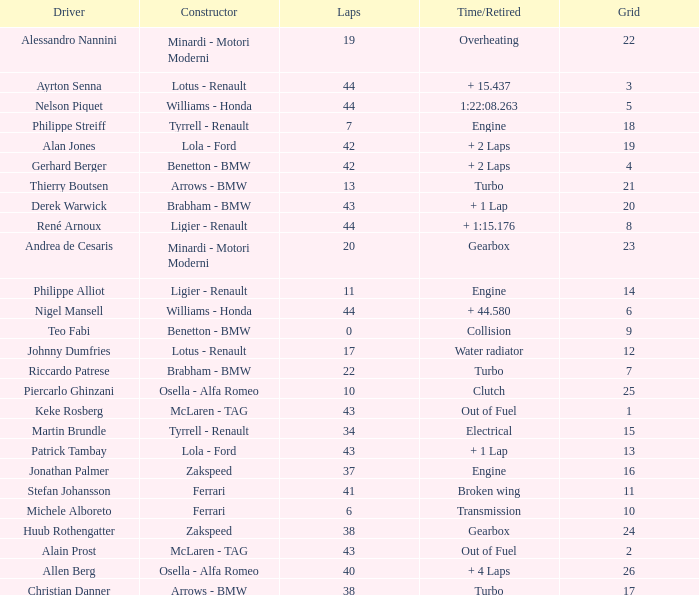I want the driver that has Laps of 10 Piercarlo Ghinzani. Can you give me this table as a dict? {'header': ['Driver', 'Constructor', 'Laps', 'Time/Retired', 'Grid'], 'rows': [['Alessandro Nannini', 'Minardi - Motori Moderni', '19', 'Overheating', '22'], ['Ayrton Senna', 'Lotus - Renault', '44', '+ 15.437', '3'], ['Nelson Piquet', 'Williams - Honda', '44', '1:22:08.263', '5'], ['Philippe Streiff', 'Tyrrell - Renault', '7', 'Engine', '18'], ['Alan Jones', 'Lola - Ford', '42', '+ 2 Laps', '19'], ['Gerhard Berger', 'Benetton - BMW', '42', '+ 2 Laps', '4'], ['Thierry Boutsen', 'Arrows - BMW', '13', 'Turbo', '21'], ['Derek Warwick', 'Brabham - BMW', '43', '+ 1 Lap', '20'], ['René Arnoux', 'Ligier - Renault', '44', '+ 1:15.176', '8'], ['Andrea de Cesaris', 'Minardi - Motori Moderni', '20', 'Gearbox', '23'], ['Philippe Alliot', 'Ligier - Renault', '11', 'Engine', '14'], ['Nigel Mansell', 'Williams - Honda', '44', '+ 44.580', '6'], ['Teo Fabi', 'Benetton - BMW', '0', 'Collision', '9'], ['Johnny Dumfries', 'Lotus - Renault', '17', 'Water radiator', '12'], ['Riccardo Patrese', 'Brabham - BMW', '22', 'Turbo', '7'], ['Piercarlo Ghinzani', 'Osella - Alfa Romeo', '10', 'Clutch', '25'], ['Keke Rosberg', 'McLaren - TAG', '43', 'Out of Fuel', '1'], ['Martin Brundle', 'Tyrrell - Renault', '34', 'Electrical', '15'], ['Patrick Tambay', 'Lola - Ford', '43', '+ 1 Lap', '13'], ['Jonathan Palmer', 'Zakspeed', '37', 'Engine', '16'], ['Stefan Johansson', 'Ferrari', '41', 'Broken wing', '11'], ['Michele Alboreto', 'Ferrari', '6', 'Transmission', '10'], ['Huub Rothengatter', 'Zakspeed', '38', 'Gearbox', '24'], ['Alain Prost', 'McLaren - TAG', '43', 'Out of Fuel', '2'], ['Allen Berg', 'Osella - Alfa Romeo', '40', '+ 4 Laps', '26'], ['Christian Danner', 'Arrows - BMW', '38', 'Turbo', '17']]} 